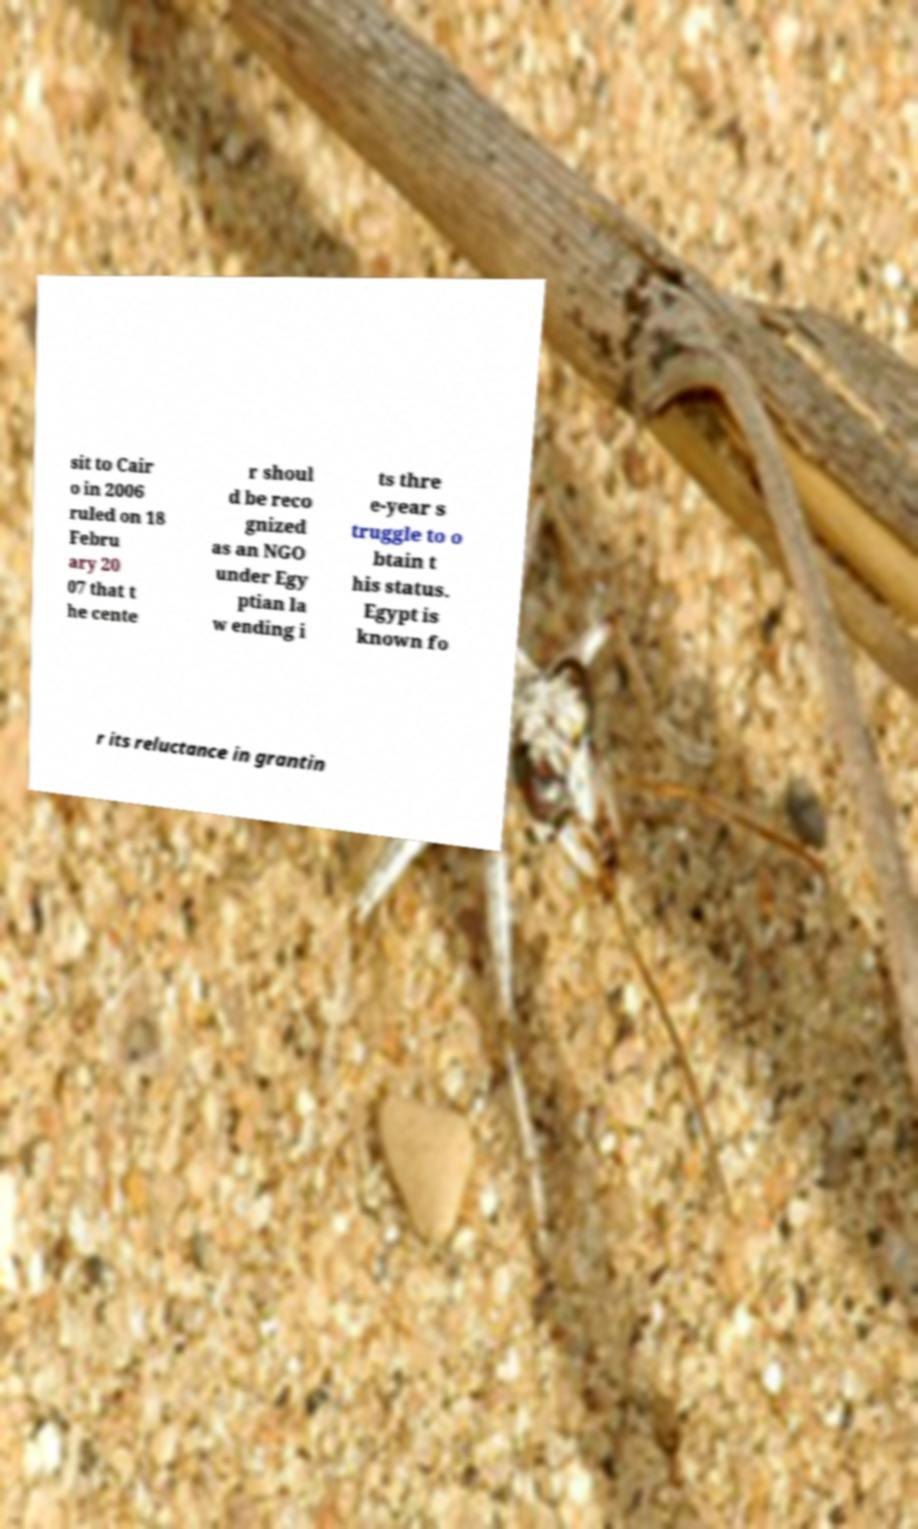Could you extract and type out the text from this image? sit to Cair o in 2006 ruled on 18 Febru ary 20 07 that t he cente r shoul d be reco gnized as an NGO under Egy ptian la w ending i ts thre e-year s truggle to o btain t his status. Egypt is known fo r its reluctance in grantin 